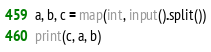<code> <loc_0><loc_0><loc_500><loc_500><_Python_>a, b, c = map(int, input().split())
print(c, a, b)</code> 